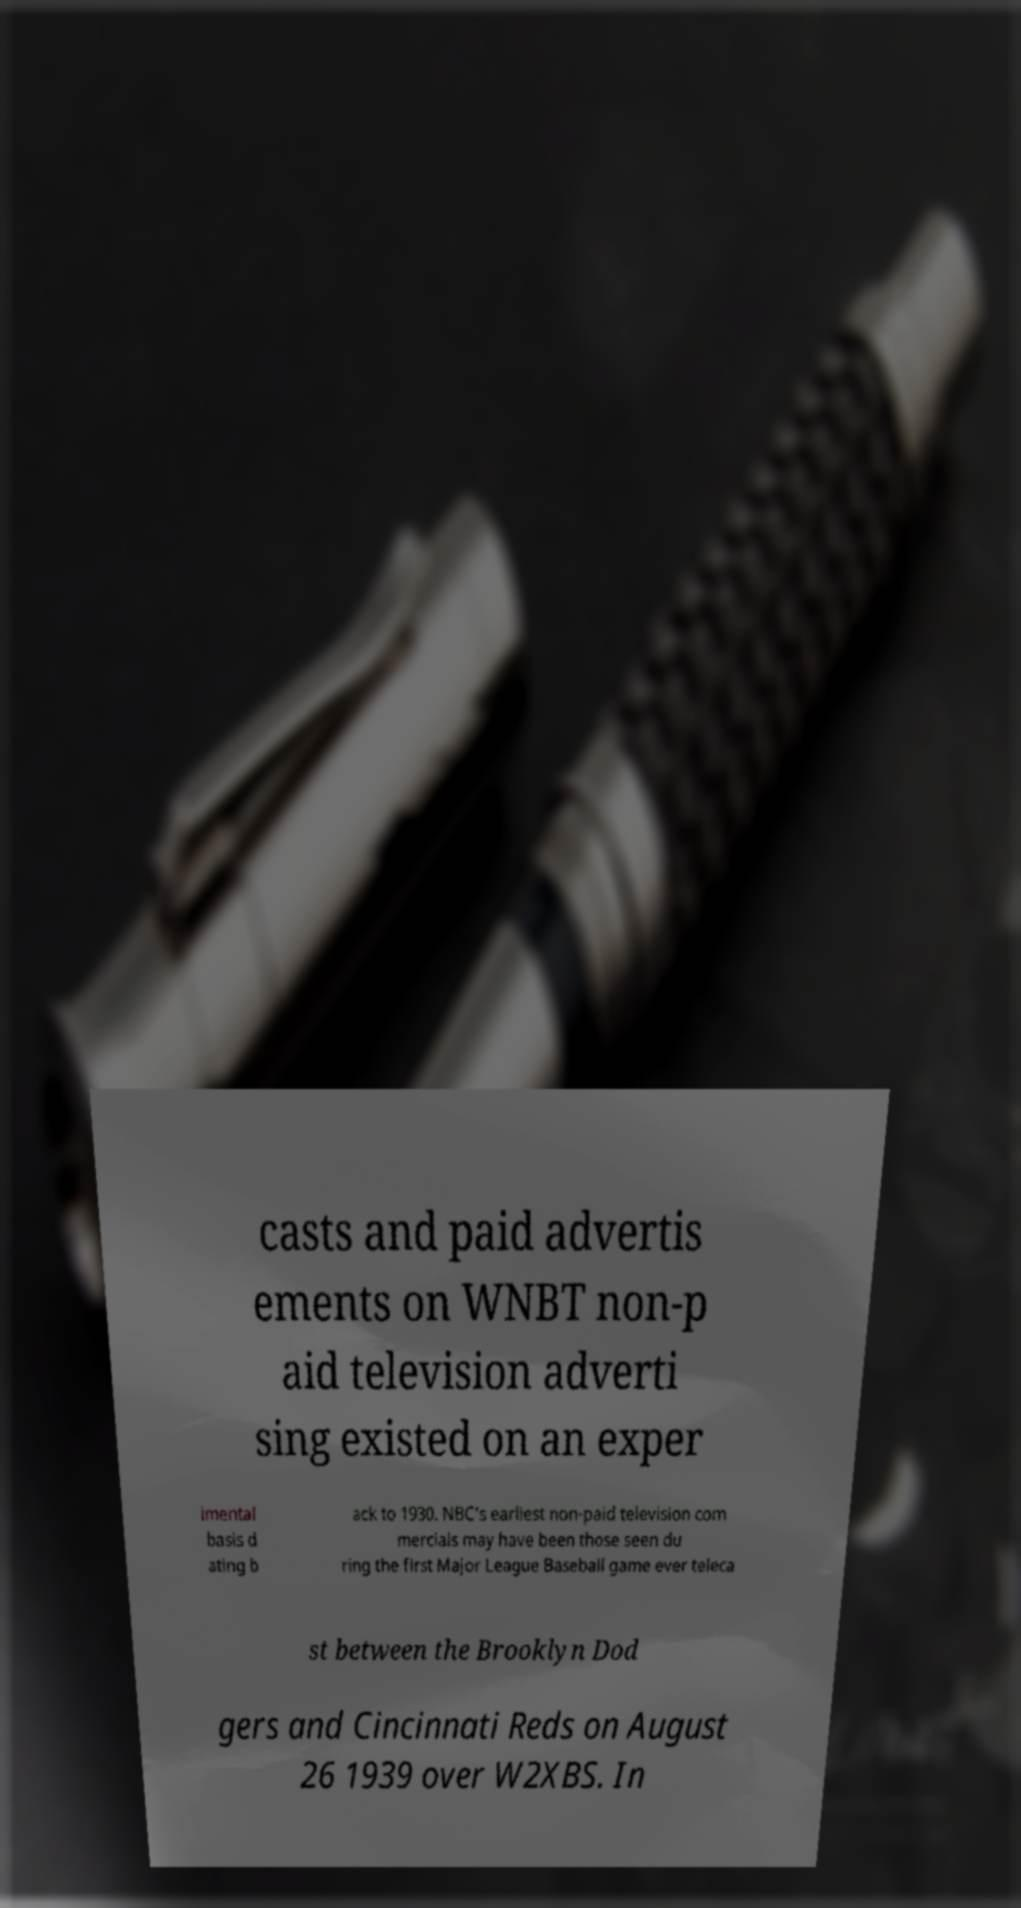What messages or text are displayed in this image? I need them in a readable, typed format. casts and paid advertis ements on WNBT non-p aid television adverti sing existed on an exper imental basis d ating b ack to 1930. NBC's earliest non-paid television com mercials may have been those seen du ring the first Major League Baseball game ever teleca st between the Brooklyn Dod gers and Cincinnati Reds on August 26 1939 over W2XBS. In 